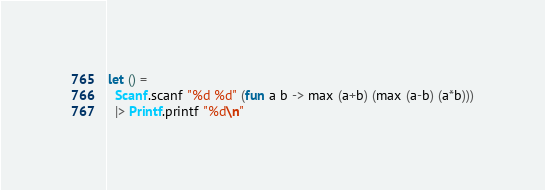<code> <loc_0><loc_0><loc_500><loc_500><_OCaml_>let () =
  Scanf.scanf "%d %d" (fun a b -> max (a+b) (max (a-b) (a*b)))
  |> Printf.printf "%d\n"</code> 